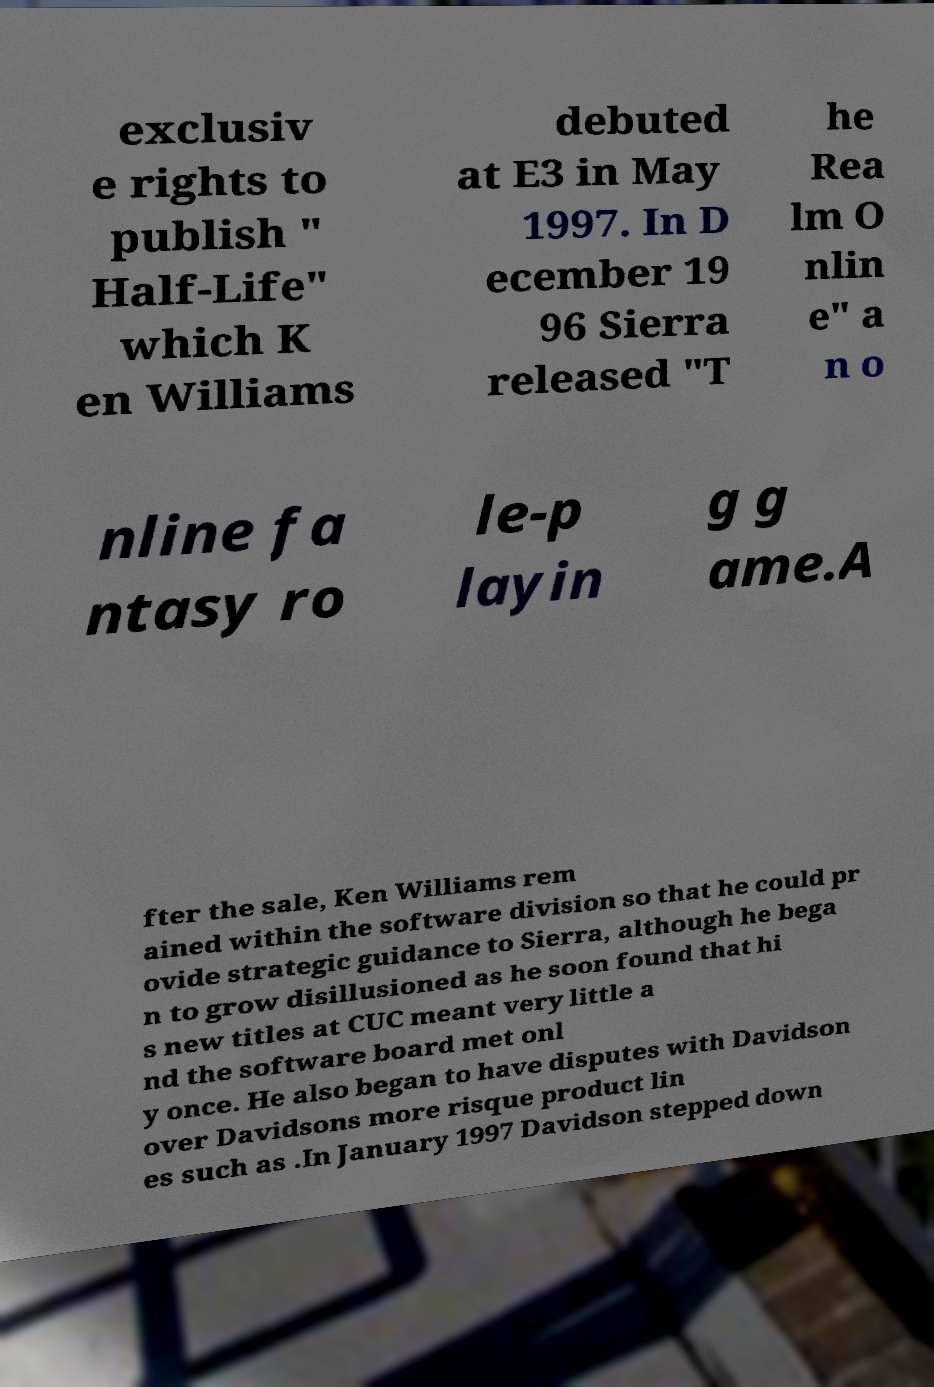I need the written content from this picture converted into text. Can you do that? exclusiv e rights to publish " Half-Life" which K en Williams debuted at E3 in May 1997. In D ecember 19 96 Sierra released "T he Rea lm O nlin e" a n o nline fa ntasy ro le-p layin g g ame.A fter the sale, Ken Williams rem ained within the software division so that he could pr ovide strategic guidance to Sierra, although he bega n to grow disillusioned as he soon found that hi s new titles at CUC meant very little a nd the software board met onl y once. He also began to have disputes with Davidson over Davidsons more risque product lin es such as .In January 1997 Davidson stepped down 